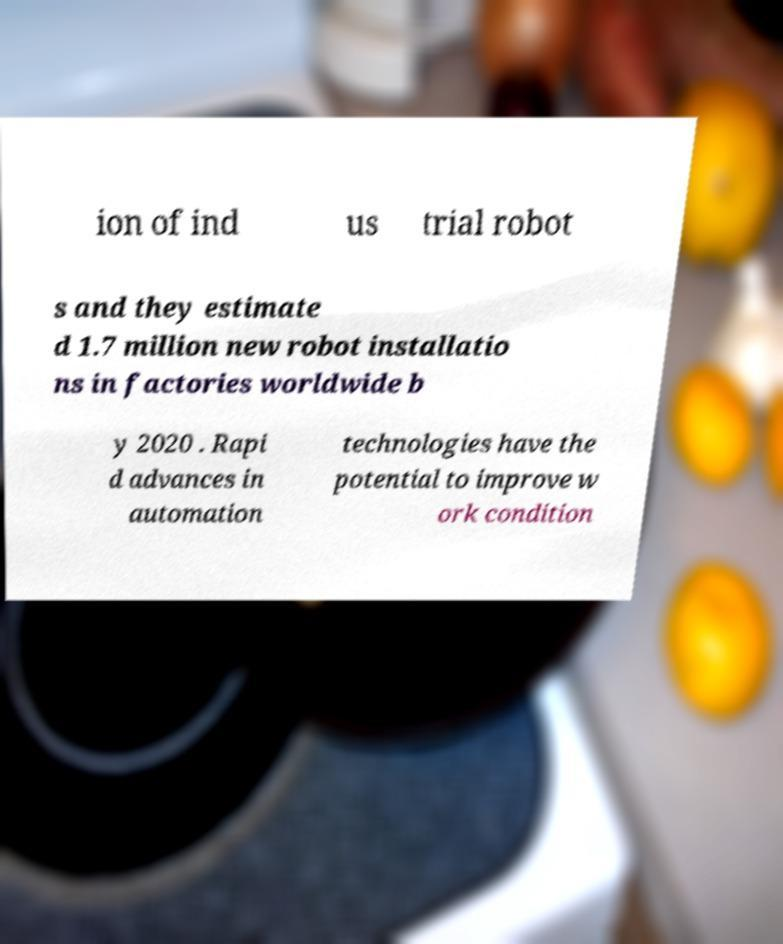For documentation purposes, I need the text within this image transcribed. Could you provide that? ion of ind us trial robot s and they estimate d 1.7 million new robot installatio ns in factories worldwide b y 2020 . Rapi d advances in automation technologies have the potential to improve w ork condition 